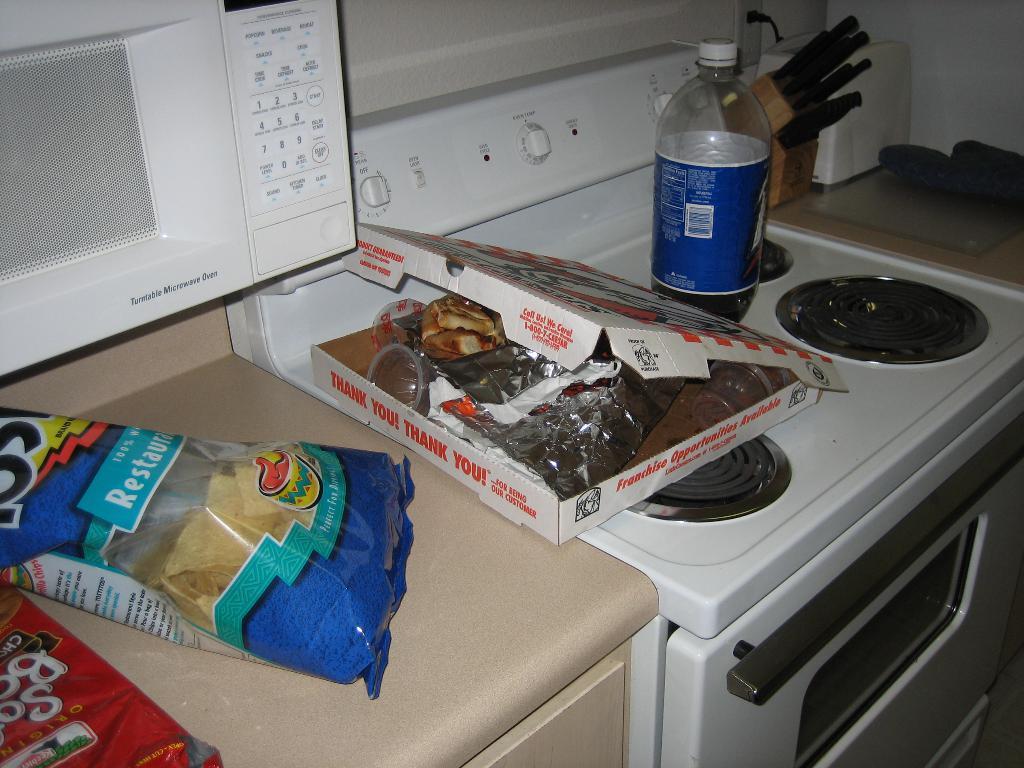What is written on the side of the pizza box?
Give a very brief answer. Thank you! thank you!. What kind are the chips?
Offer a terse response. Tostitos. 